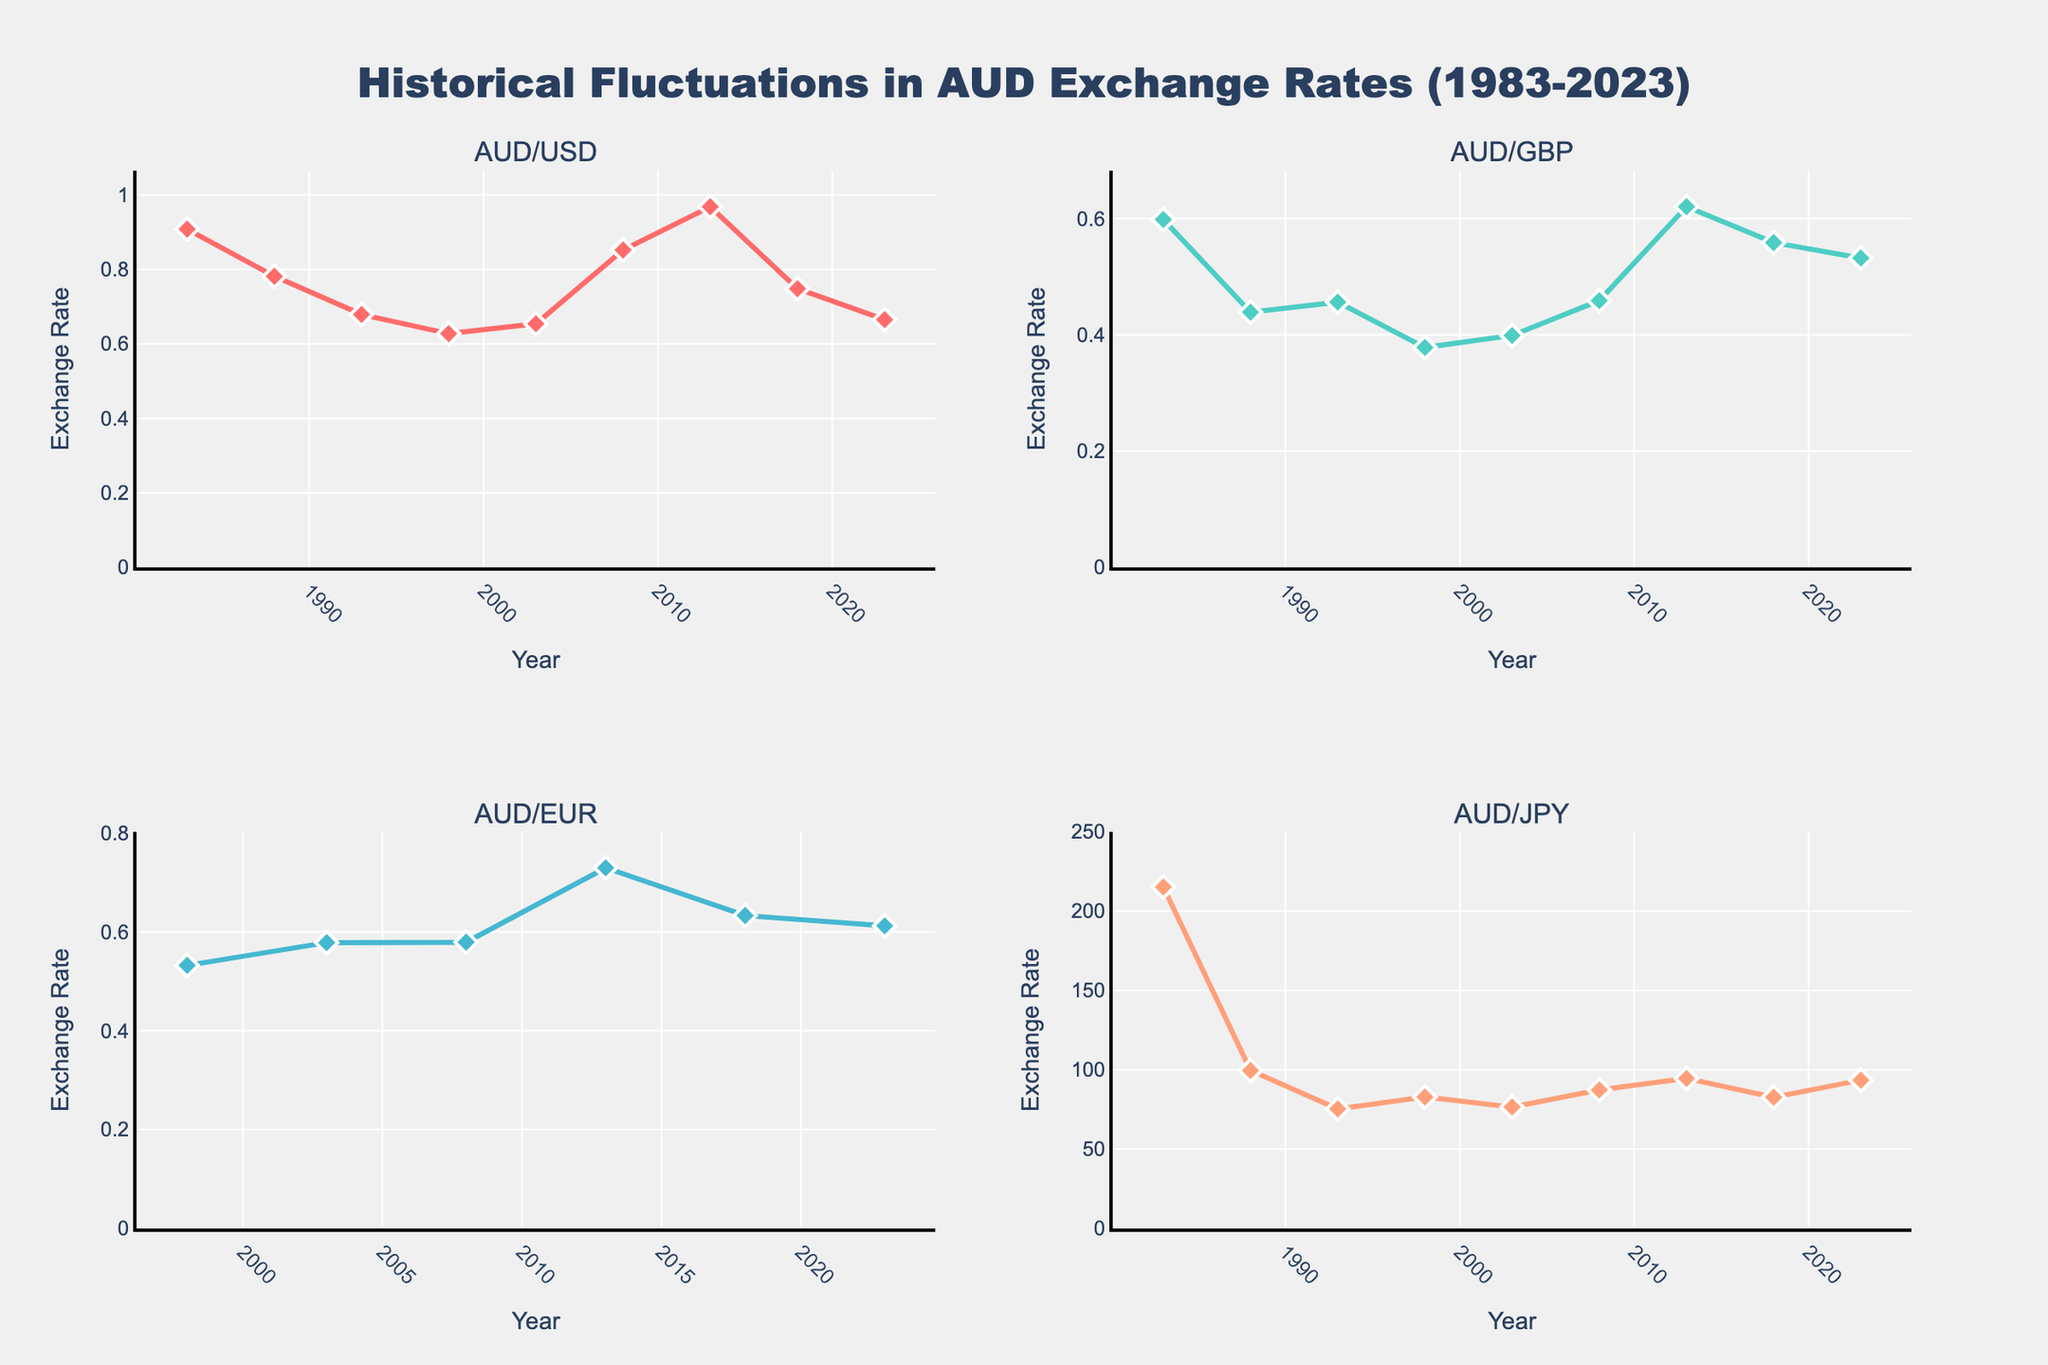What is the highest exchange rate for AUD/USD between 1983 and 2023? The highest exchange rate can be identified by looking at the peak of the red line in the AUD/USD subplot. In this case, the highest point is at 2013 with an exchange rate of 0.9683
Answer: 0.9683 Which year did the AUD/USD exchange rate first fall below 0.70? We can find the first point where the red line in the AUD/USD subplot drops below the 0.70 mark. It occurs in the year 1993
Answer: 1993 What is the difference between the maximum exchange rates for AUD/GBP and AUD/JPY? First, identify the maximum exchange rates for each currency. For AUD/GBP (teal line), the highest value is 0.6204 in 2013. For AUD/JPY (salmon line), it is 215.23 in 1983. The difference is 215.23 - 0.6204 = 214.6096
Answer: 214.6096 In which year did all the available exchange rates experience a decline compared to their previous year's values? By observing the trends in all four subplots, we look for a year where each currency's line shows a downward slope compared to the previous point. Between 2013 and 2018, all currencies declined: AUD/USD from 0.9683 to 0.7480, AUD/GBP from 0.6204 to 0.5586, AUD/EUR from 0.7294 to 0.6330, and AUD/JPY from 94.55 to 82.72
Answer: 2018 Which subplot shows the most significant fluctuation throughout the years? By comparing the vertical distance covered by each line in the subplots, the one with the largest overall variation is AUD/JPY (salmon line), which ranges from 215.23 in 1983 to around 75-94 in later years
Answer: AUD/JPY What has been the general trend of the AUD/EUR exchange rate since it first appeared in 1998? Observing the green line in the AUD/EUR subplot, we can see its trend: it starts around 0.5321 in 1998, rises, peaks around 0.7294 in 2013, then generally declines to 0.6121 in 2023
Answer: Generally increasing, then decreasing How did the AUD/USD rate change from 2008 to 2013? Locate the red line in the AUD/USD subplot and note that it goes from 0.8519 in 2008 to 0.9683 in 2013, indicating an increase
Answer: Increased What is the average value of the AUD/GBP exchange rate from 1983 to 2023? Calculate the mean by adding the exchange rates for AUD/GBP in the AUD/GBP subplot (0.5983, 0.4389, 0.4562, 0.3782, 0.3989, 0.4588, 0.6204, 0.5586, 0.5321) and dividing by 9. The sum is 4.4404, so 4.4404/9 = 0.4934
Answer: 0.4934 Which currency exchange rate experienced the greatest decrease from one point to another? By examining all subplots, find the point where the most significant drop occurs between two consecutive years. The AUD/JPY subplot shows the largest drop from 215.23 in 1983 to 99.56 in 1988, a difference of 115.67
Answer: 115.67 